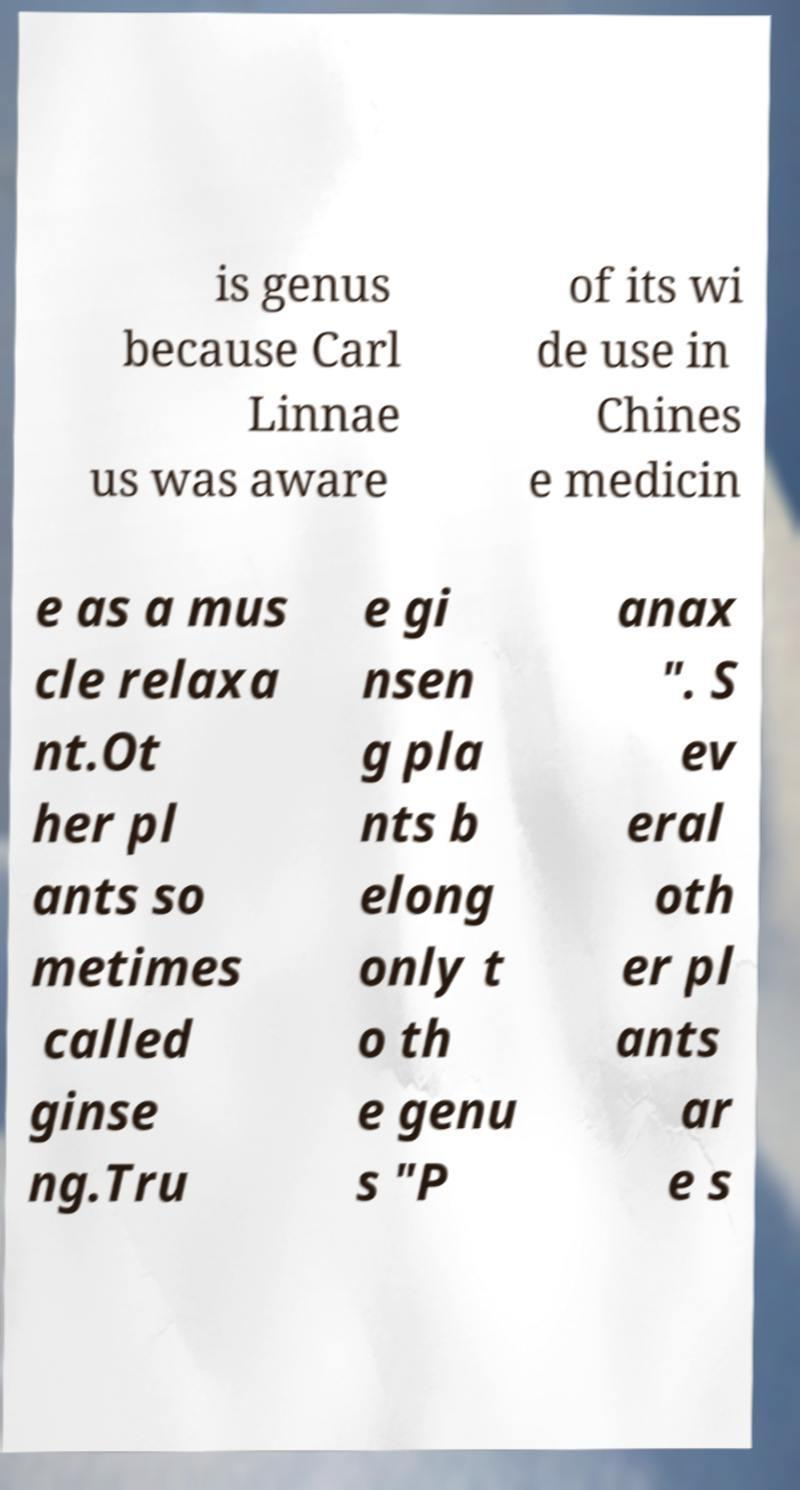I need the written content from this picture converted into text. Can you do that? is genus because Carl Linnae us was aware of its wi de use in Chines e medicin e as a mus cle relaxa nt.Ot her pl ants so metimes called ginse ng.Tru e gi nsen g pla nts b elong only t o th e genu s "P anax ". S ev eral oth er pl ants ar e s 